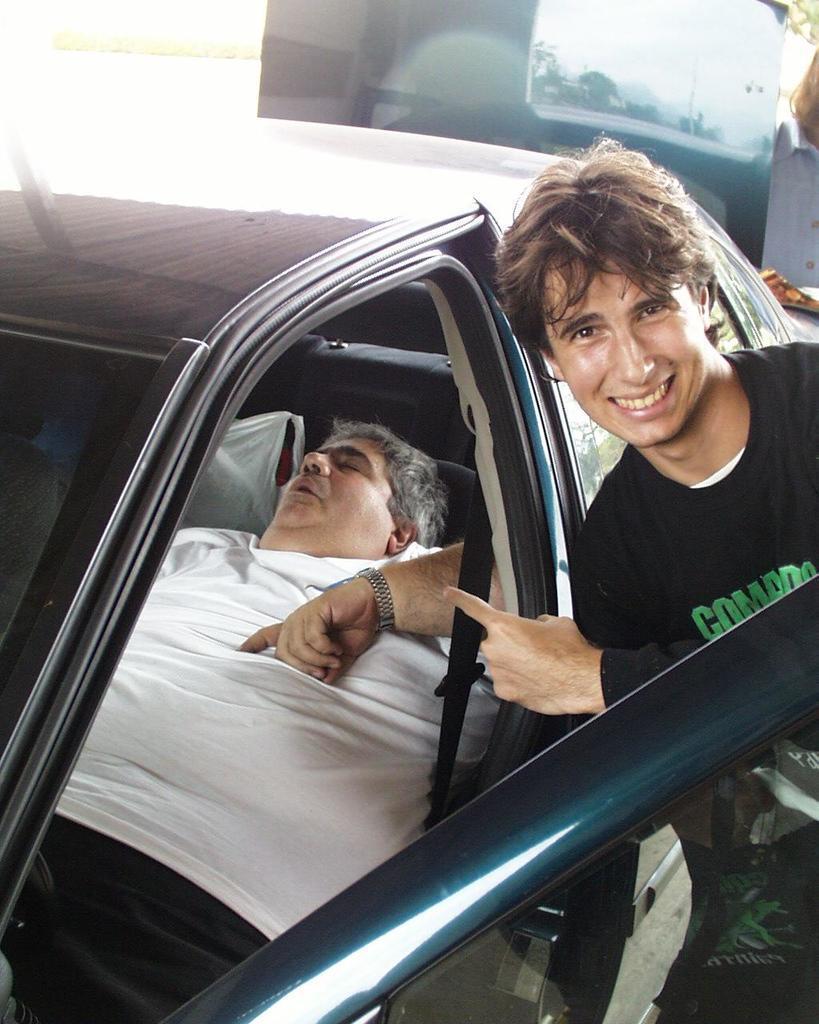Describe this image in one or two sentences. There is a man in this picture smiling and another man in the car seat, sleeping. 